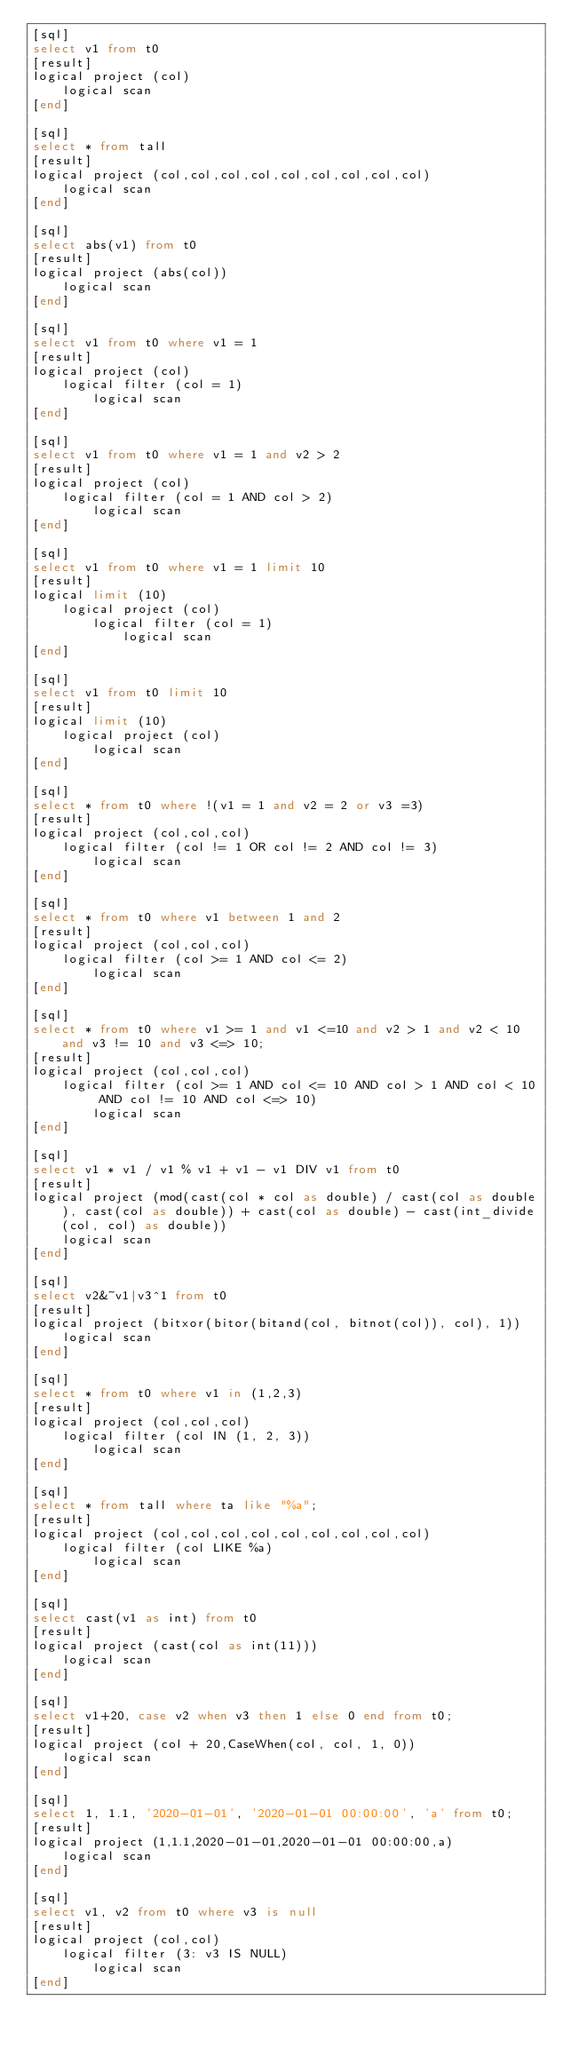<code> <loc_0><loc_0><loc_500><loc_500><_SQL_>[sql]
select v1 from t0
[result]
logical project (col)
    logical scan
[end]

[sql]
select * from tall
[result]
logical project (col,col,col,col,col,col,col,col,col)
    logical scan
[end]

[sql]
select abs(v1) from t0
[result]
logical project (abs(col))
    logical scan
[end]

[sql]
select v1 from t0 where v1 = 1
[result]
logical project (col)
    logical filter (col = 1)
        logical scan
[end]

[sql]
select v1 from t0 where v1 = 1 and v2 > 2
[result]
logical project (col)
    logical filter (col = 1 AND col > 2)
        logical scan
[end]

[sql]
select v1 from t0 where v1 = 1 limit 10
[result]
logical limit (10)
    logical project (col)
        logical filter (col = 1)
            logical scan
[end]

[sql]
select v1 from t0 limit 10
[result]
logical limit (10)
    logical project (col)
        logical scan
[end]

[sql]
select * from t0 where !(v1 = 1 and v2 = 2 or v3 =3)
[result]
logical project (col,col,col)
    logical filter (col != 1 OR col != 2 AND col != 3)
        logical scan
[end]

[sql]
select * from t0 where v1 between 1 and 2
[result]
logical project (col,col,col)
    logical filter (col >= 1 AND col <= 2)
        logical scan
[end]

[sql]
select * from t0 where v1 >= 1 and v1 <=10 and v2 > 1 and v2 < 10 and v3 != 10 and v3 <=> 10;
[result]
logical project (col,col,col)
    logical filter (col >= 1 AND col <= 10 AND col > 1 AND col < 10 AND col != 10 AND col <=> 10)
        logical scan
[end]

[sql]
select v1 * v1 / v1 % v1 + v1 - v1 DIV v1 from t0
[result]
logical project (mod(cast(col * col as double) / cast(col as double), cast(col as double)) + cast(col as double) - cast(int_divide(col, col) as double))
    logical scan
[end]

[sql]
select v2&~v1|v3^1 from t0
[result]
logical project (bitxor(bitor(bitand(col, bitnot(col)), col), 1))
    logical scan
[end]

[sql]
select * from t0 where v1 in (1,2,3)
[result]
logical project (col,col,col)
    logical filter (col IN (1, 2, 3))
        logical scan
[end]

[sql]
select * from tall where ta like "%a";
[result]
logical project (col,col,col,col,col,col,col,col,col)
    logical filter (col LIKE %a)
        logical scan
[end]

[sql]
select cast(v1 as int) from t0
[result]
logical project (cast(col as int(11)))
    logical scan
[end]

[sql]
select v1+20, case v2 when v3 then 1 else 0 end from t0;
[result]
logical project (col + 20,CaseWhen(col, col, 1, 0))
    logical scan
[end]

[sql]
select 1, 1.1, '2020-01-01', '2020-01-01 00:00:00', 'a' from t0;
[result]
logical project (1,1.1,2020-01-01,2020-01-01 00:00:00,a)
    logical scan
[end]

[sql]
select v1, v2 from t0 where v3 is null
[result]
logical project (col,col)
    logical filter (3: v3 IS NULL)
        logical scan
[end]</code> 